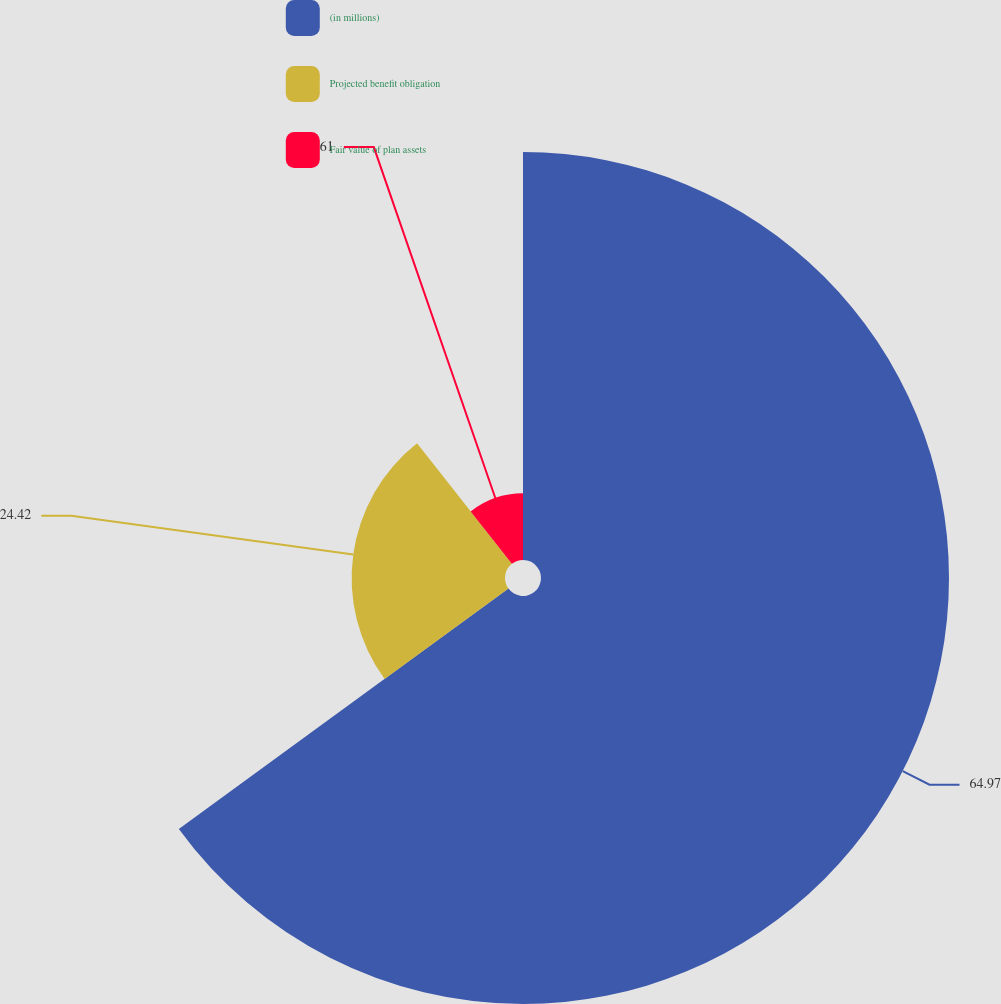<chart> <loc_0><loc_0><loc_500><loc_500><pie_chart><fcel>(in millions)<fcel>Projected benefit obligation<fcel>Fair value of plan assets<nl><fcel>64.97%<fcel>24.42%<fcel>10.61%<nl></chart> 